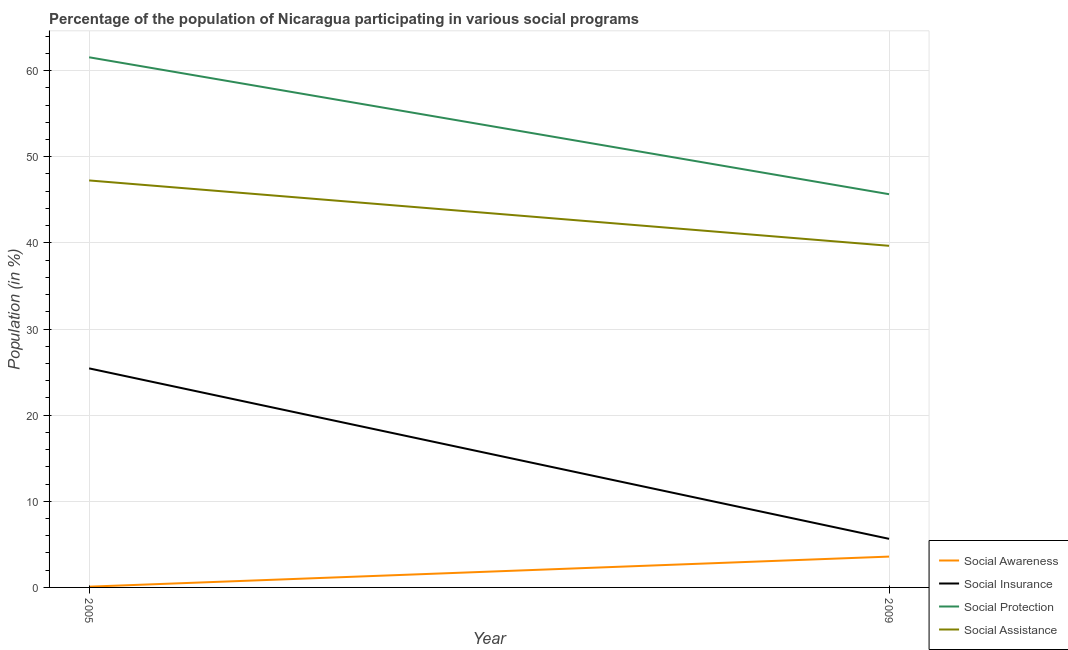How many different coloured lines are there?
Provide a succinct answer. 4. Does the line corresponding to participation of population in social insurance programs intersect with the line corresponding to participation of population in social protection programs?
Keep it short and to the point. No. What is the participation of population in social assistance programs in 2009?
Keep it short and to the point. 39.66. Across all years, what is the maximum participation of population in social assistance programs?
Offer a very short reply. 47.25. Across all years, what is the minimum participation of population in social awareness programs?
Offer a terse response. 0.09. In which year was the participation of population in social protection programs minimum?
Keep it short and to the point. 2009. What is the total participation of population in social awareness programs in the graph?
Ensure brevity in your answer.  3.66. What is the difference between the participation of population in social awareness programs in 2005 and that in 2009?
Give a very brief answer. -3.49. What is the difference between the participation of population in social protection programs in 2009 and the participation of population in social awareness programs in 2005?
Provide a succinct answer. 45.56. What is the average participation of population in social awareness programs per year?
Offer a very short reply. 1.83. In the year 2005, what is the difference between the participation of population in social awareness programs and participation of population in social insurance programs?
Your response must be concise. -25.34. What is the ratio of the participation of population in social insurance programs in 2005 to that in 2009?
Make the answer very short. 4.51. Is the participation of population in social assistance programs in 2005 less than that in 2009?
Provide a succinct answer. No. In how many years, is the participation of population in social insurance programs greater than the average participation of population in social insurance programs taken over all years?
Your response must be concise. 1. Is it the case that in every year, the sum of the participation of population in social assistance programs and participation of population in social awareness programs is greater than the sum of participation of population in social insurance programs and participation of population in social protection programs?
Offer a terse response. No. Is it the case that in every year, the sum of the participation of population in social awareness programs and participation of population in social insurance programs is greater than the participation of population in social protection programs?
Provide a short and direct response. No. Does the participation of population in social awareness programs monotonically increase over the years?
Ensure brevity in your answer.  Yes. Is the participation of population in social assistance programs strictly greater than the participation of population in social protection programs over the years?
Ensure brevity in your answer.  No. Is the participation of population in social insurance programs strictly less than the participation of population in social protection programs over the years?
Provide a succinct answer. Yes. How many lines are there?
Keep it short and to the point. 4. Does the graph contain any zero values?
Offer a very short reply. No. Where does the legend appear in the graph?
Ensure brevity in your answer.  Bottom right. What is the title of the graph?
Make the answer very short. Percentage of the population of Nicaragua participating in various social programs . Does "Business regulatory environment" appear as one of the legend labels in the graph?
Provide a succinct answer. No. What is the label or title of the X-axis?
Offer a very short reply. Year. What is the label or title of the Y-axis?
Your response must be concise. Population (in %). What is the Population (in %) of Social Awareness in 2005?
Offer a terse response. 0.09. What is the Population (in %) of Social Insurance in 2005?
Your answer should be compact. 25.43. What is the Population (in %) of Social Protection in 2005?
Your response must be concise. 61.55. What is the Population (in %) of Social Assistance in 2005?
Offer a very short reply. 47.25. What is the Population (in %) of Social Awareness in 2009?
Provide a short and direct response. 3.58. What is the Population (in %) of Social Insurance in 2009?
Provide a short and direct response. 5.64. What is the Population (in %) in Social Protection in 2009?
Give a very brief answer. 45.65. What is the Population (in %) of Social Assistance in 2009?
Provide a short and direct response. 39.66. Across all years, what is the maximum Population (in %) of Social Awareness?
Offer a very short reply. 3.58. Across all years, what is the maximum Population (in %) in Social Insurance?
Provide a short and direct response. 25.43. Across all years, what is the maximum Population (in %) of Social Protection?
Your answer should be very brief. 61.55. Across all years, what is the maximum Population (in %) in Social Assistance?
Provide a succinct answer. 47.25. Across all years, what is the minimum Population (in %) in Social Awareness?
Make the answer very short. 0.09. Across all years, what is the minimum Population (in %) in Social Insurance?
Ensure brevity in your answer.  5.64. Across all years, what is the minimum Population (in %) of Social Protection?
Provide a succinct answer. 45.65. Across all years, what is the minimum Population (in %) of Social Assistance?
Your answer should be compact. 39.66. What is the total Population (in %) in Social Awareness in the graph?
Ensure brevity in your answer.  3.67. What is the total Population (in %) in Social Insurance in the graph?
Ensure brevity in your answer.  31.07. What is the total Population (in %) of Social Protection in the graph?
Your answer should be compact. 107.2. What is the total Population (in %) in Social Assistance in the graph?
Your answer should be very brief. 86.91. What is the difference between the Population (in %) in Social Awareness in 2005 and that in 2009?
Give a very brief answer. -3.49. What is the difference between the Population (in %) in Social Insurance in 2005 and that in 2009?
Offer a very short reply. 19.79. What is the difference between the Population (in %) of Social Protection in 2005 and that in 2009?
Your answer should be compact. 15.89. What is the difference between the Population (in %) of Social Assistance in 2005 and that in 2009?
Give a very brief answer. 7.59. What is the difference between the Population (in %) of Social Awareness in 2005 and the Population (in %) of Social Insurance in 2009?
Keep it short and to the point. -5.55. What is the difference between the Population (in %) of Social Awareness in 2005 and the Population (in %) of Social Protection in 2009?
Keep it short and to the point. -45.56. What is the difference between the Population (in %) of Social Awareness in 2005 and the Population (in %) of Social Assistance in 2009?
Your answer should be compact. -39.57. What is the difference between the Population (in %) in Social Insurance in 2005 and the Population (in %) in Social Protection in 2009?
Offer a terse response. -20.22. What is the difference between the Population (in %) of Social Insurance in 2005 and the Population (in %) of Social Assistance in 2009?
Provide a succinct answer. -14.23. What is the difference between the Population (in %) of Social Protection in 2005 and the Population (in %) of Social Assistance in 2009?
Make the answer very short. 21.89. What is the average Population (in %) of Social Awareness per year?
Your response must be concise. 1.83. What is the average Population (in %) in Social Insurance per year?
Offer a very short reply. 15.53. What is the average Population (in %) of Social Protection per year?
Provide a short and direct response. 53.6. What is the average Population (in %) in Social Assistance per year?
Your answer should be very brief. 43.45. In the year 2005, what is the difference between the Population (in %) in Social Awareness and Population (in %) in Social Insurance?
Make the answer very short. -25.34. In the year 2005, what is the difference between the Population (in %) in Social Awareness and Population (in %) in Social Protection?
Provide a short and direct response. -61.46. In the year 2005, what is the difference between the Population (in %) in Social Awareness and Population (in %) in Social Assistance?
Offer a very short reply. -47.16. In the year 2005, what is the difference between the Population (in %) of Social Insurance and Population (in %) of Social Protection?
Your answer should be very brief. -36.12. In the year 2005, what is the difference between the Population (in %) of Social Insurance and Population (in %) of Social Assistance?
Give a very brief answer. -21.82. In the year 2005, what is the difference between the Population (in %) in Social Protection and Population (in %) in Social Assistance?
Make the answer very short. 14.3. In the year 2009, what is the difference between the Population (in %) of Social Awareness and Population (in %) of Social Insurance?
Your answer should be very brief. -2.06. In the year 2009, what is the difference between the Population (in %) in Social Awareness and Population (in %) in Social Protection?
Provide a succinct answer. -42.07. In the year 2009, what is the difference between the Population (in %) in Social Awareness and Population (in %) in Social Assistance?
Offer a terse response. -36.08. In the year 2009, what is the difference between the Population (in %) of Social Insurance and Population (in %) of Social Protection?
Your answer should be very brief. -40.01. In the year 2009, what is the difference between the Population (in %) of Social Insurance and Population (in %) of Social Assistance?
Your answer should be very brief. -34.02. In the year 2009, what is the difference between the Population (in %) of Social Protection and Population (in %) of Social Assistance?
Make the answer very short. 5.99. What is the ratio of the Population (in %) of Social Awareness in 2005 to that in 2009?
Ensure brevity in your answer.  0.02. What is the ratio of the Population (in %) of Social Insurance in 2005 to that in 2009?
Give a very brief answer. 4.51. What is the ratio of the Population (in %) of Social Protection in 2005 to that in 2009?
Keep it short and to the point. 1.35. What is the ratio of the Population (in %) of Social Assistance in 2005 to that in 2009?
Provide a short and direct response. 1.19. What is the difference between the highest and the second highest Population (in %) of Social Awareness?
Make the answer very short. 3.49. What is the difference between the highest and the second highest Population (in %) in Social Insurance?
Your answer should be very brief. 19.79. What is the difference between the highest and the second highest Population (in %) in Social Protection?
Give a very brief answer. 15.89. What is the difference between the highest and the second highest Population (in %) in Social Assistance?
Your answer should be compact. 7.59. What is the difference between the highest and the lowest Population (in %) of Social Awareness?
Keep it short and to the point. 3.49. What is the difference between the highest and the lowest Population (in %) of Social Insurance?
Offer a terse response. 19.79. What is the difference between the highest and the lowest Population (in %) of Social Protection?
Give a very brief answer. 15.89. What is the difference between the highest and the lowest Population (in %) in Social Assistance?
Your response must be concise. 7.59. 